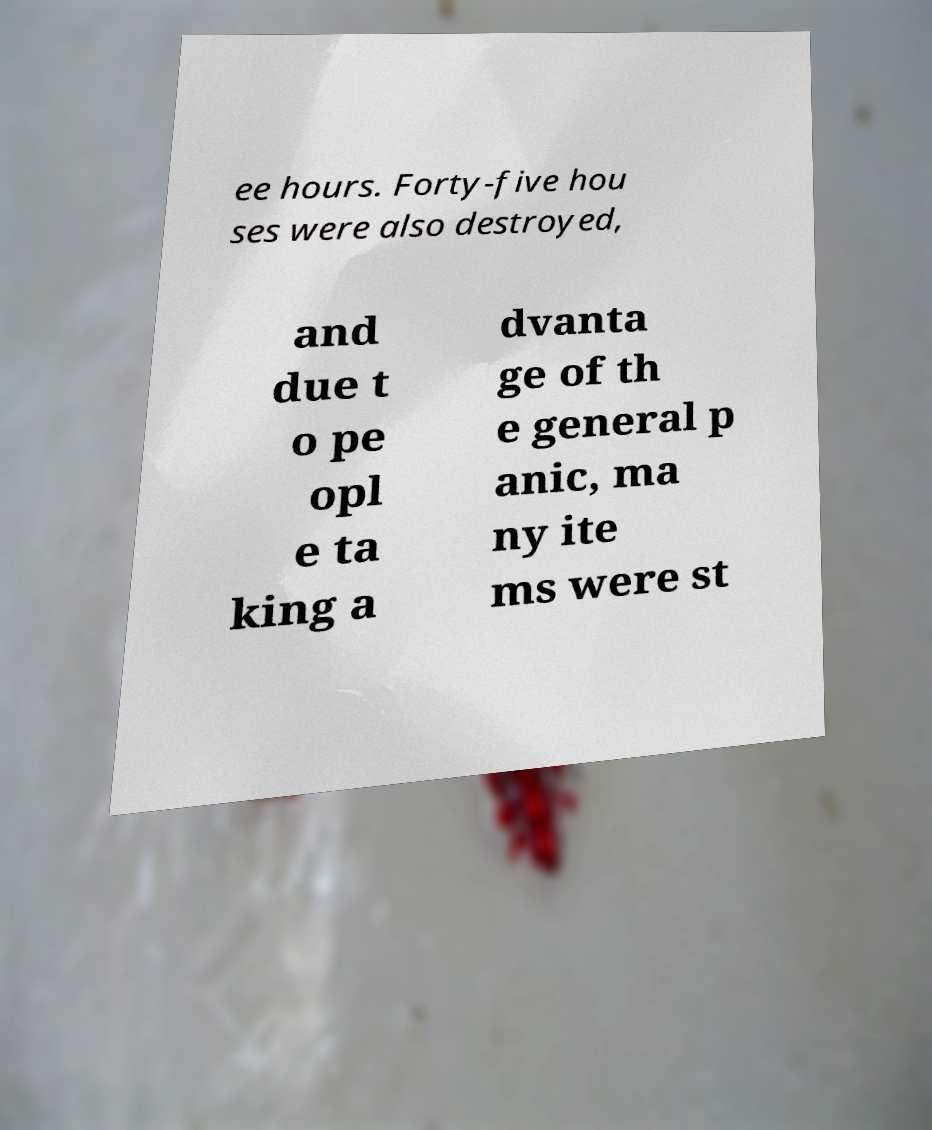Please read and relay the text visible in this image. What does it say? ee hours. Forty-five hou ses were also destroyed, and due t o pe opl e ta king a dvanta ge of th e general p anic, ma ny ite ms were st 